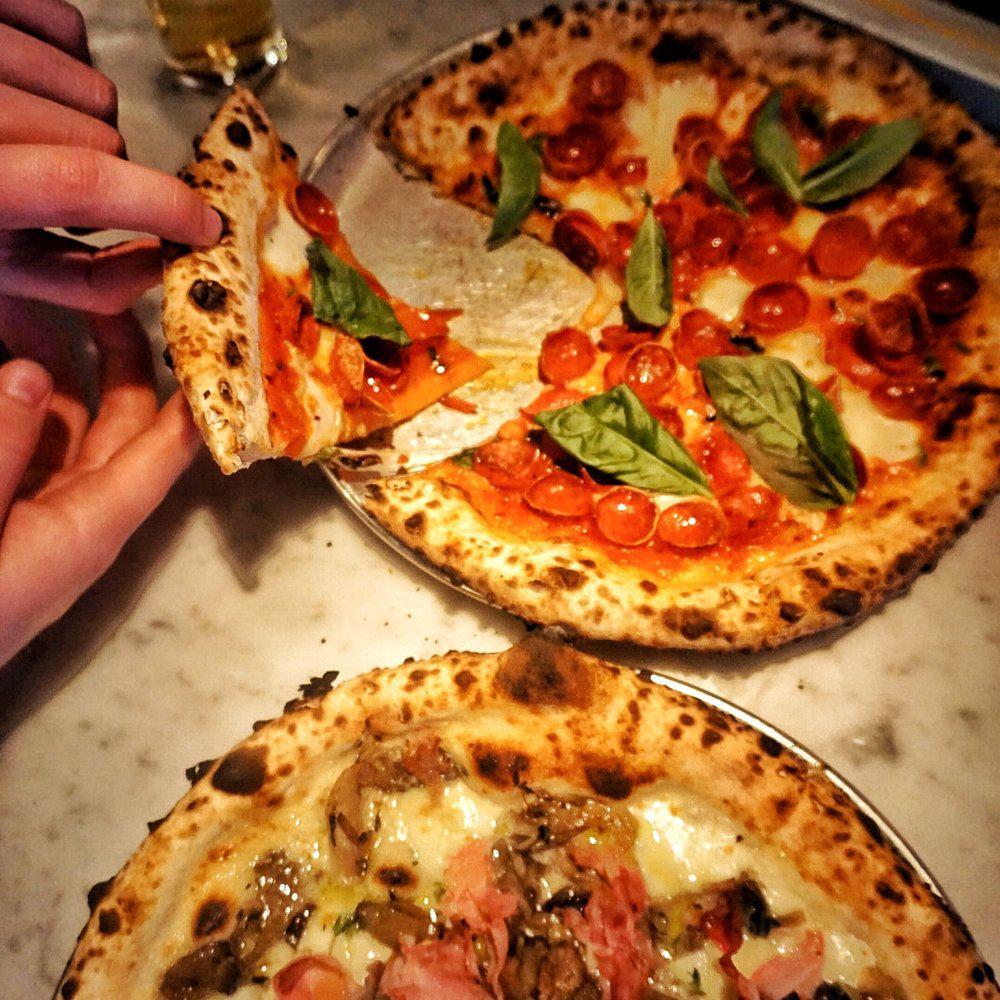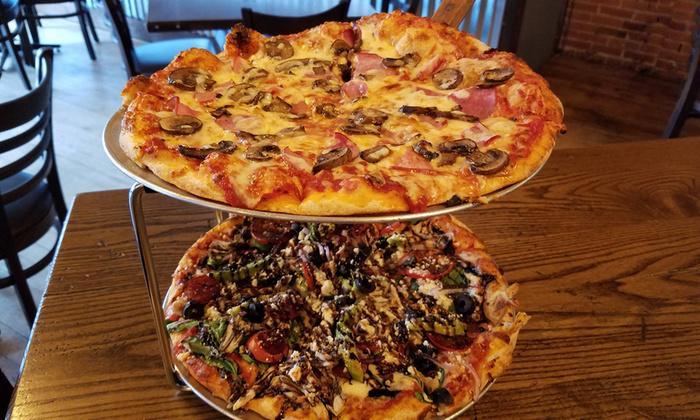The first image is the image on the left, the second image is the image on the right. Analyze the images presented: Is the assertion "Four pizzas are visible." valid? Answer yes or no. Yes. The first image is the image on the left, the second image is the image on the right. Examine the images to the left and right. Is the description "In the left image a slice is being lifted off the pizza." accurate? Answer yes or no. Yes. 